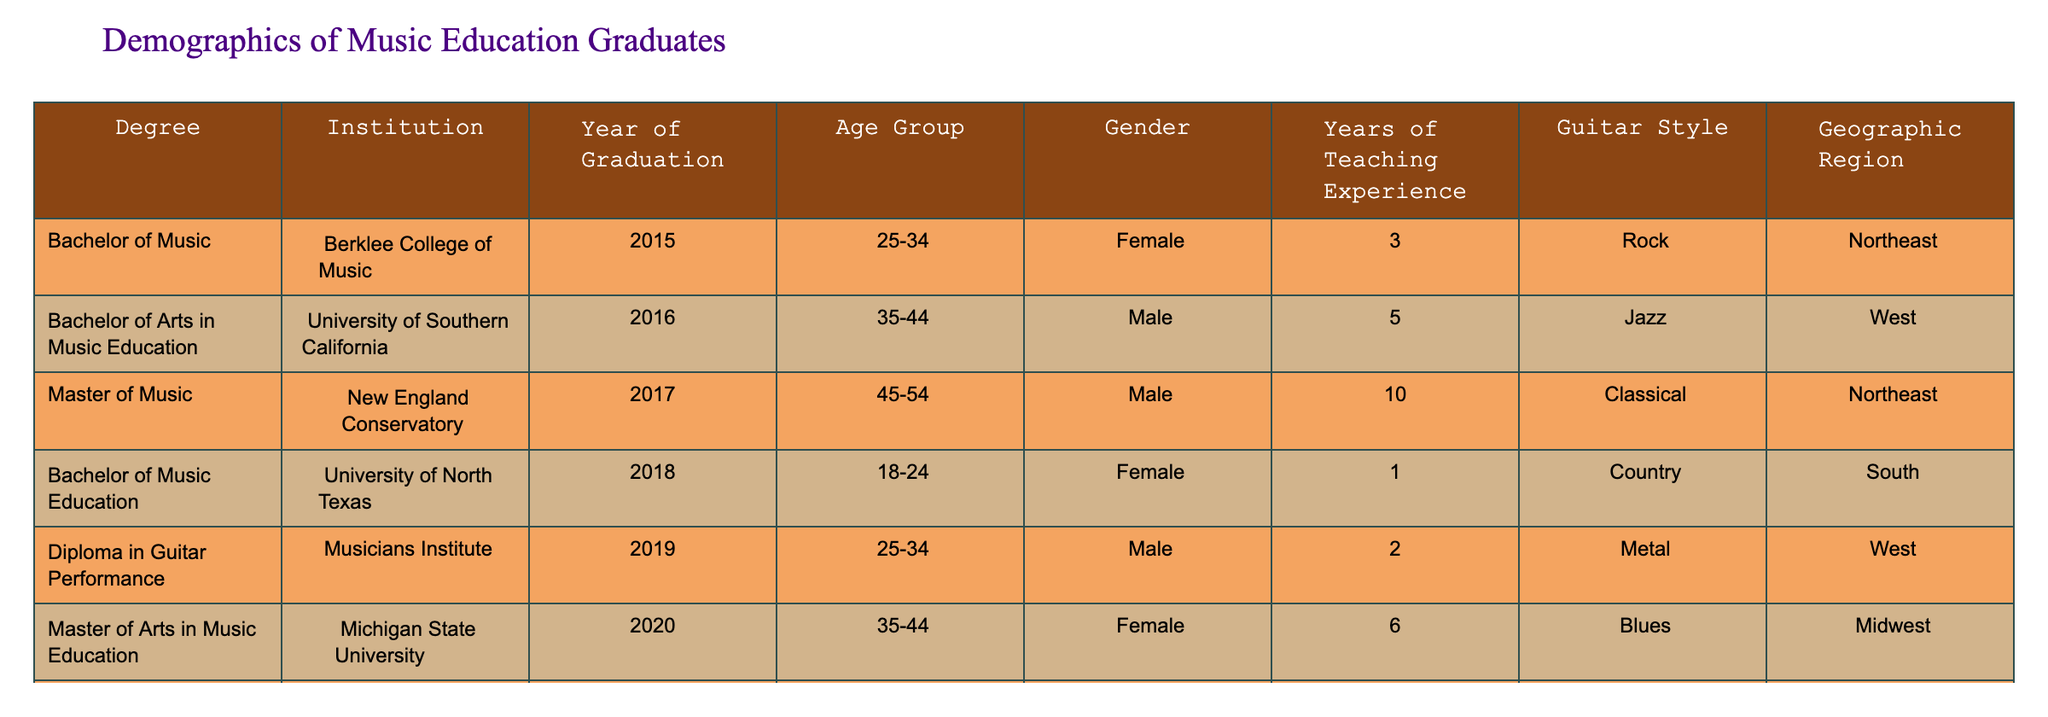What is the most common guitar style among the graduates? By reviewing the 'Guitar Style' column, the most frequently appearing style is 'Rock', which appears in the table for one graduate from Berklee College of Music.
Answer: Rock How many graduates are there in the age group 35-44? Looking at the 'Age Group' column, there are two entries (one male from the University of Southern California and one female from Michigan State University) that fall into the 35-44 category.
Answer: 2 What is the average years of teaching experience for graduates? To calculate the average, we sum the years of teaching experience: (3 + 5 + 10 + 1 + 2 + 6 + 3 + 0) = 30 years. There are 8 graduates, so the average is 30/8 = 3.75 years.
Answer: 3.75 Are there more female or male graduates? From the gender column, there are four female graduates (Berklee, North Texas, Michigan State, Indiana University) and four male graduates (University of Southern California, New England Conservatory, Musicians Institute, University of Oregon). Therefore, it is equal.
Answer: No Which geographic region has the most graduates? By counting the occurrences in the 'Geographic Region' column, the 'West' region appears three times (University of Southern California, Musicians Institute, and University of Oregon), while 'Northeast', 'South', and 'Midwest' appear twice, once, and twice, respectively. Thus, the region with the most graduates is the West.
Answer: West What is the difference in years of teaching experience between the oldest and youngest graduates? The graduate with the most experience is from the New England Conservatory with 10 years, and the youngest graduate from the University of North Texas has 1 year. The difference is 10 - 1 = 9 years.
Answer: 9 Is there any graduate with a specialization in "Alternative" and "Blues"? There is one graduate specializing in "Alternative" from Indiana University and one in "Blues" from Michigan State University. However, they are different individuals, meaning none specializes in both styles.
Answer: No How many graduates have a master’s degree? In the 'Degree' column, there are two entries indicating a master’s degree: one from New England Conservatory and one from Michigan State University.
Answer: 2 What is the median age group of the graduates? The age groups recorded are 18-24, 25-34, 35-44, and 45-54. Sorting them gives 18-24, 25-34, 35-44, 45-54. There are 8 graduates, so the median lies between the 4th and 5th. The middle age groups are "35-44" and "25-34", thus the median age group is between these two.
Answer: 25-34, 35-44 (median spans these two groups) 